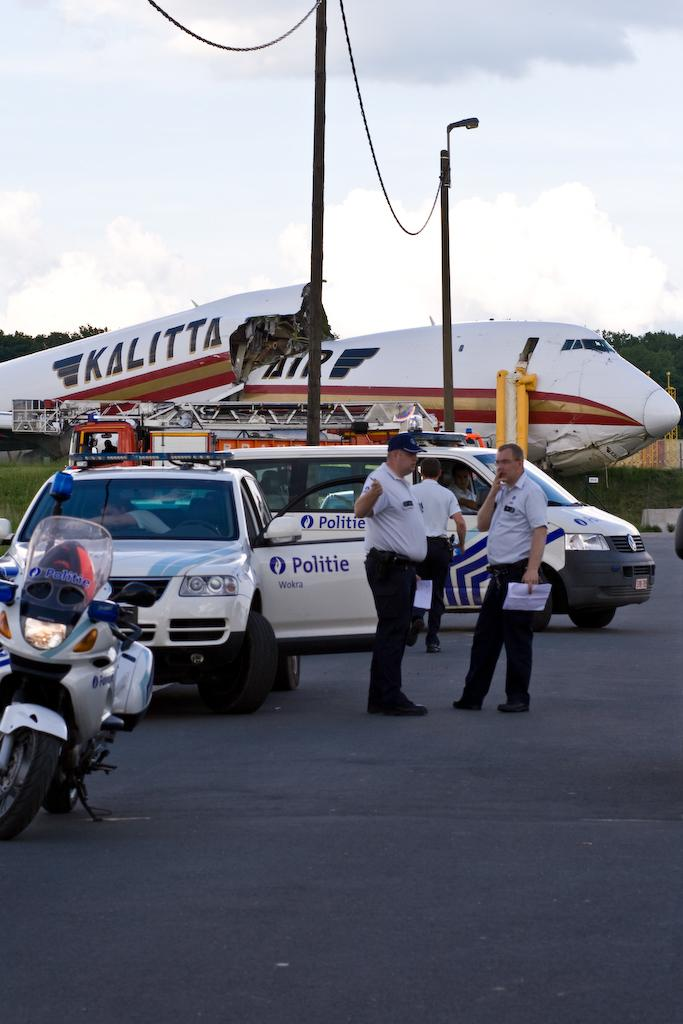What are the people in the image doing? The people in the image are standing on the road. What else can be seen on the road besides the people? There are vehicles on the road. What can be seen in the image besides the road and vehicles? There are trees and pole lights with wires in the image. What is visible in the background of the image? There is an aeroplane and the sky visible in the background of the image. Can you see a guitar being played by someone in the image? No, there is no guitar present in the image. What type of plant is growing near the pole lights in the image? There are no plants visible in the image; only trees, vehicles, and people can be seen. 